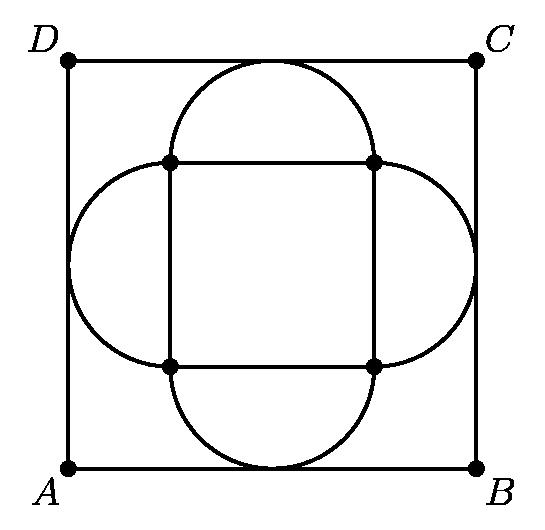Around the outside of a $4$ by $4$ square, construct four semicircles with the four sides of the square as their diameters. Another square, $ABCD$, has its sides parallel to the corresponding sides of the original square, and each side of $ABCD$ is tangent to one of the semicircles. What is the area of the square $ABCD$? To find the area of the square $ABCD$, we need to derive the side length of $ABCD$ by understanding its relationship with the semicircles. Since each side of $ABCD$ is tangent to a semicircle, we can set up the relationship in terms of geometry and solve for the side length. However, without an exact solution provided in the answer, we can't specify the area here. 